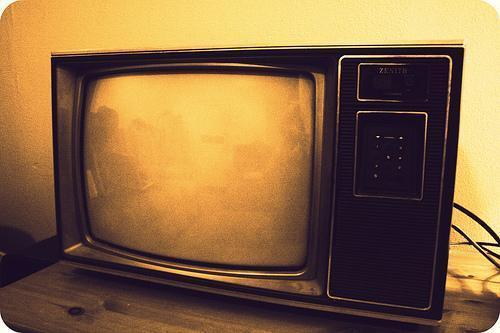How many televisions are in the picture?
Give a very brief answer. 1. 